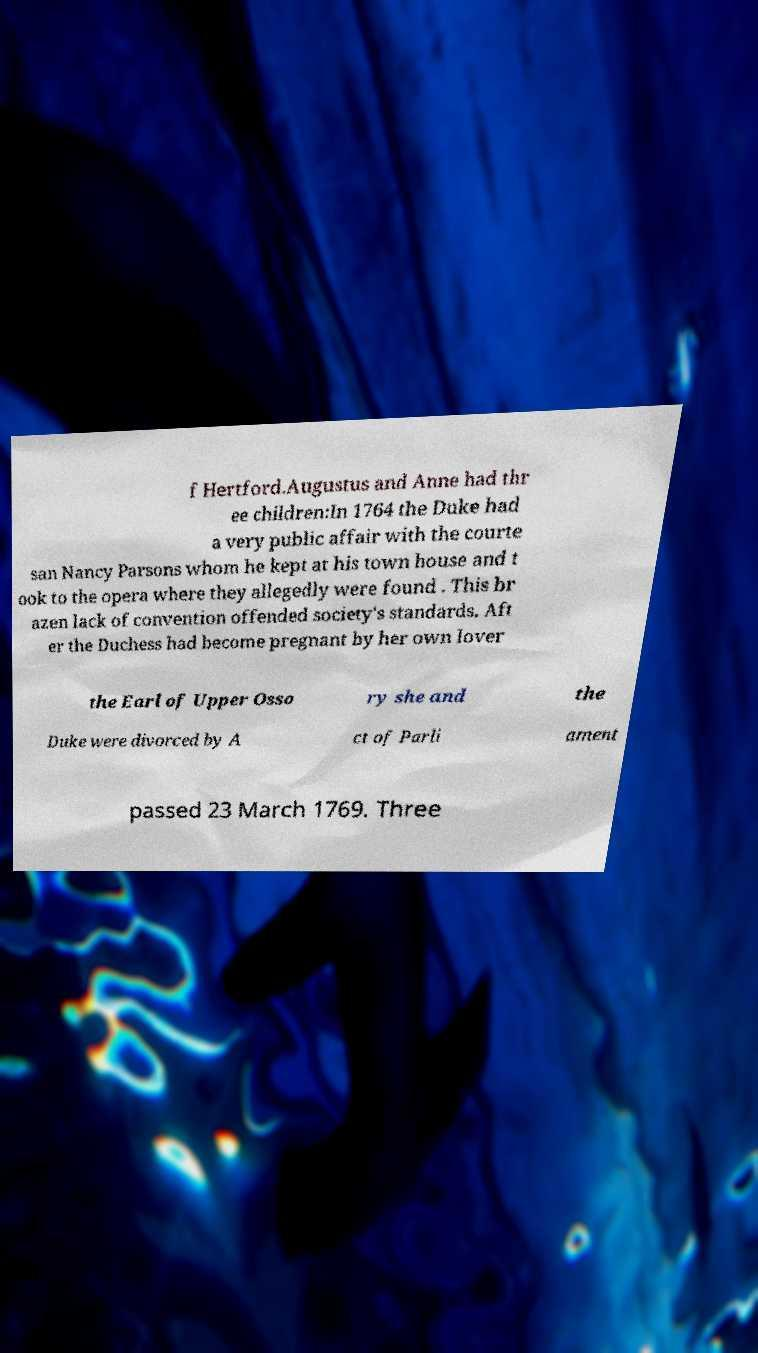Can you read and provide the text displayed in the image?This photo seems to have some interesting text. Can you extract and type it out for me? f Hertford.Augustus and Anne had thr ee children:In 1764 the Duke had a very public affair with the courte san Nancy Parsons whom he kept at his town house and t ook to the opera where they allegedly were found . This br azen lack of convention offended society's standards. Aft er the Duchess had become pregnant by her own lover the Earl of Upper Osso ry she and the Duke were divorced by A ct of Parli ament passed 23 March 1769. Three 